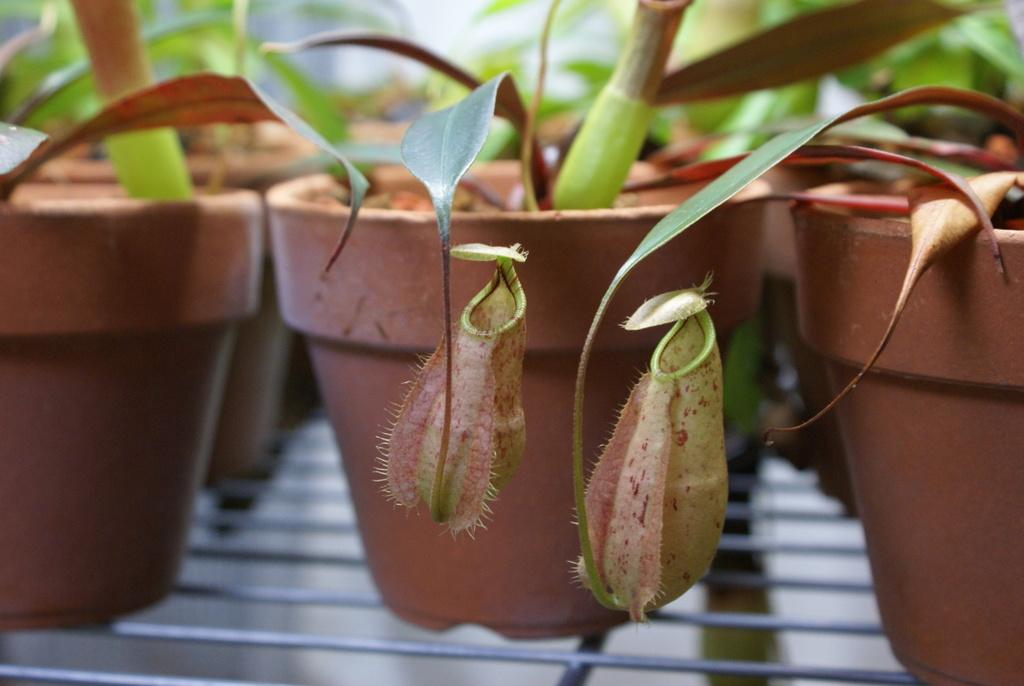What objects are present in the image that are used for growing plants? There are plant pots in the image. What color are the plant pots? The plant pots are brown in color. What is growing inside the plant pots? There are plants in the plant pots. How would you describe the background of the image? The background of the image is blurry. Can you see any tails on the plants in the image? No, plants do not have tails, so there are none visible in the image. 